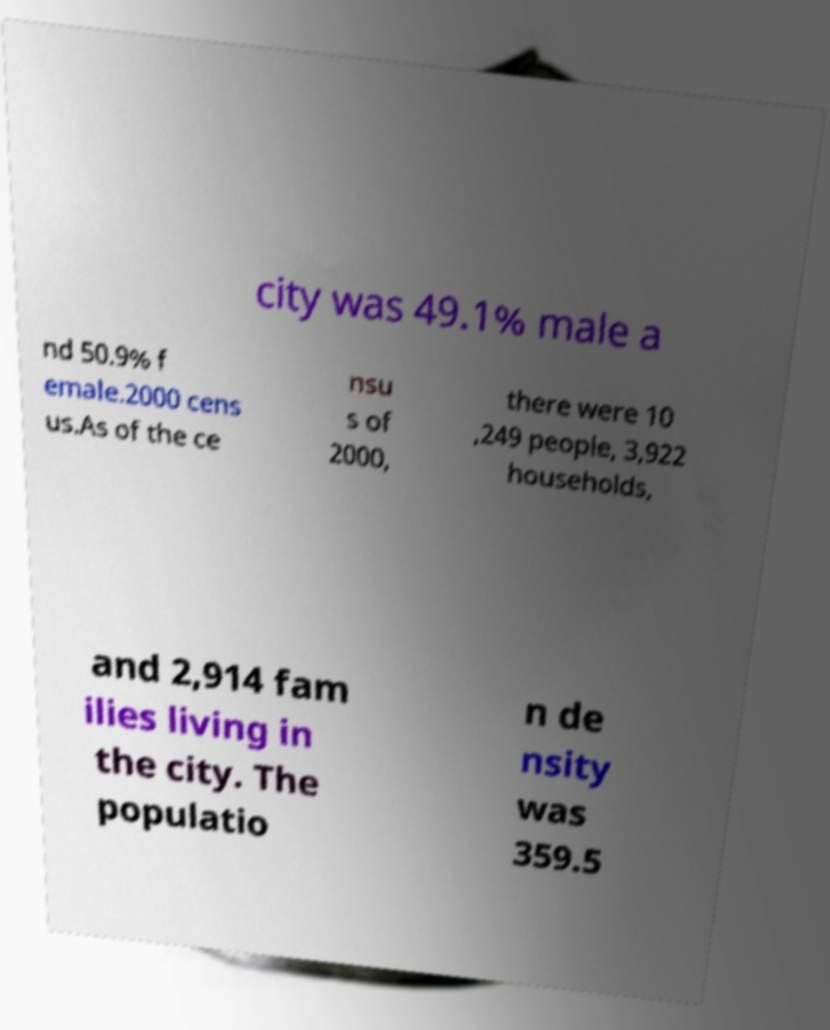What messages or text are displayed in this image? I need them in a readable, typed format. city was 49.1% male a nd 50.9% f emale.2000 cens us.As of the ce nsu s of 2000, there were 10 ,249 people, 3,922 households, and 2,914 fam ilies living in the city. The populatio n de nsity was 359.5 